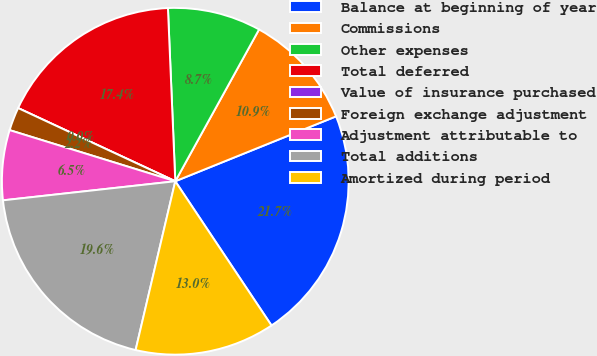Convert chart to OTSL. <chart><loc_0><loc_0><loc_500><loc_500><pie_chart><fcel>Balance at beginning of year<fcel>Commissions<fcel>Other expenses<fcel>Total deferred<fcel>Value of insurance purchased<fcel>Foreign exchange adjustment<fcel>Adjustment attributable to<fcel>Total additions<fcel>Amortized during period<nl><fcel>21.74%<fcel>10.87%<fcel>8.7%<fcel>17.39%<fcel>0.0%<fcel>2.17%<fcel>6.52%<fcel>19.57%<fcel>13.04%<nl></chart> 